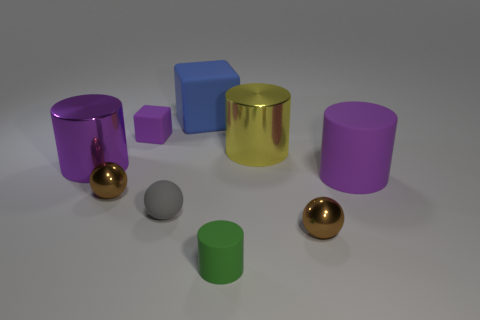Subtract all purple blocks. How many purple cylinders are left? 2 Subtract 1 cylinders. How many cylinders are left? 3 Subtract all big purple rubber cylinders. How many cylinders are left? 3 Subtract all green cylinders. How many cylinders are left? 3 Add 1 blocks. How many objects exist? 10 Subtract all cyan cylinders. Subtract all green balls. How many cylinders are left? 4 Subtract all balls. How many objects are left? 6 Add 7 tiny yellow rubber cubes. How many tiny yellow rubber cubes exist? 7 Subtract 0 purple spheres. How many objects are left? 9 Subtract all large yellow objects. Subtract all big blue rubber objects. How many objects are left? 7 